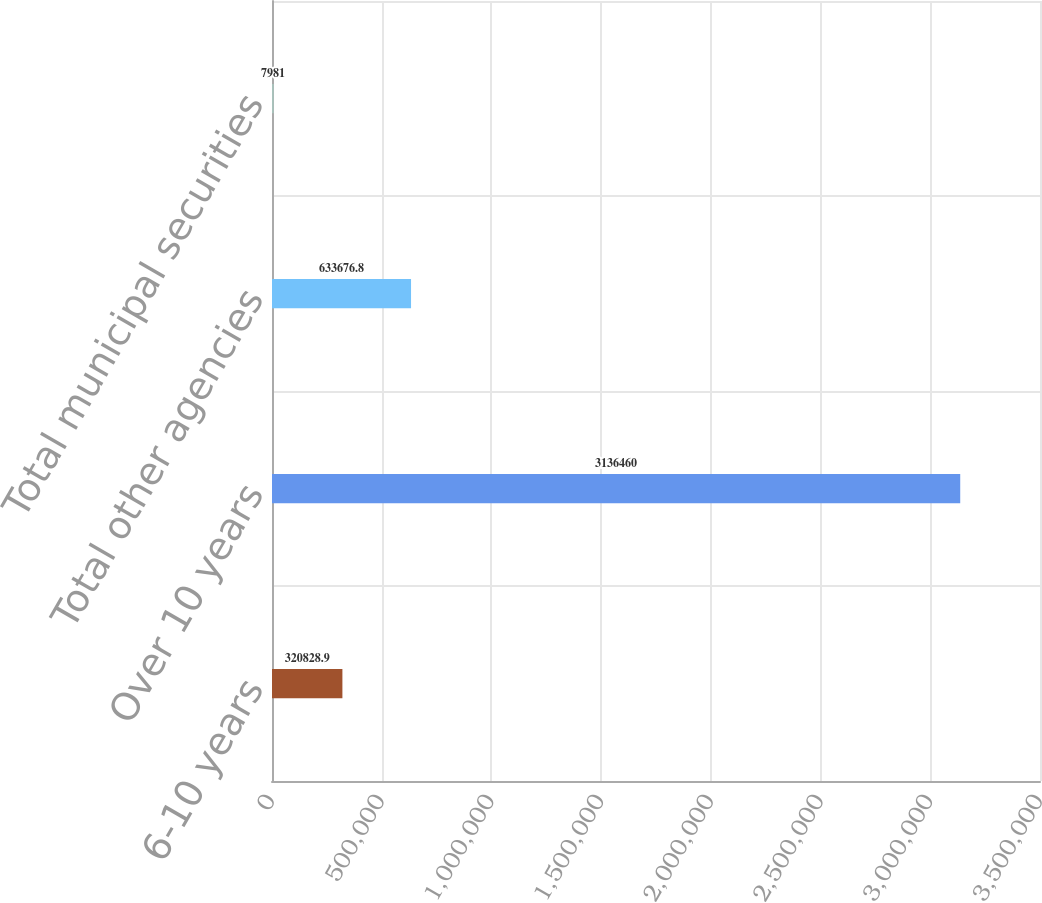<chart> <loc_0><loc_0><loc_500><loc_500><bar_chart><fcel>6-10 years<fcel>Over 10 years<fcel>Total other agencies<fcel>Total municipal securities<nl><fcel>320829<fcel>3.13646e+06<fcel>633677<fcel>7981<nl></chart> 